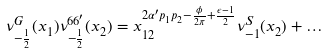Convert formula to latex. <formula><loc_0><loc_0><loc_500><loc_500>\nu ^ { G } _ { - \frac { 1 } { 2 } } ( x _ { 1 } ) \nu ^ { 6 6 ^ { \prime } } _ { - \frac { 1 } { 2 } } ( x _ { 2 } ) = x _ { 1 2 } ^ { 2 \alpha ^ { \prime } p _ { 1 } p _ { 2 } - \frac { \phi } { 2 \pi } + \frac { \epsilon - 1 } { 2 } } \nu _ { - 1 } ^ { S } ( x _ { 2 } ) + \dots</formula> 